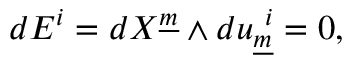<formula> <loc_0><loc_0><loc_500><loc_500>d E ^ { i } = d X ^ { \underline { m } } \wedge d u _ { \underline { m } } ^ { i } = 0 ,</formula> 